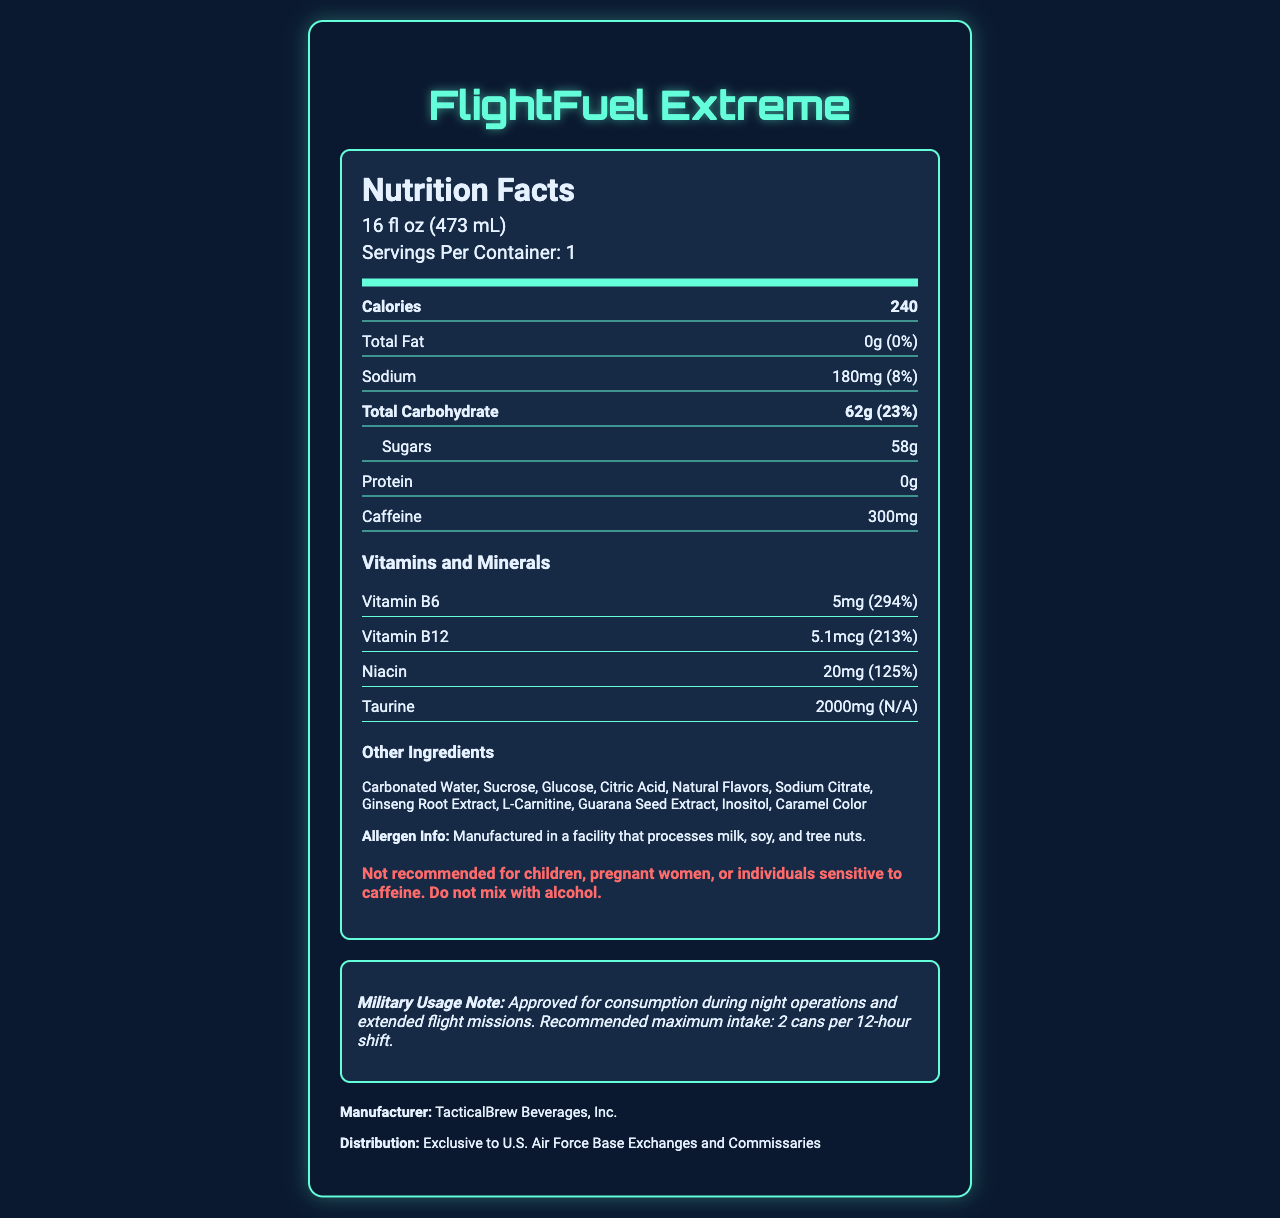what is the serving size of FlightFuel Extreme? The serving size is clearly mentioned near the top of the nutrition label.
Answer: 16 fl oz (473 mL) how many calories does one serving of FlightFuel Extreme contain? It is stated in the prominent "Calories" section of the label.
Answer: 240 what is the total carbohydrate content per serving? The amount is specifically listed under the "Total Carbohydrate" section in the nutrition label.
Answer: 62g what percentage of the daily value of sodium does one serving provide? This information is included next to the sodium content in the nutrition label.
Answer: 8% what are the two main sugars listed in FlightFuel Extreme? These sugars are listed under the "Other Ingredients" section.
Answer: Sucrose and Glucose what is the total fat content in FlightFuel Extreme? The total fat content is listed as 0g with a daily value of 0%.
Answer: 0g which vitamin is present in the highest percentage of daily value in FlightFuel Extreme? A. Vitamin B6 B. Vitamin B12 C. Niacin Vitamin B6 has 294% of the daily value, which is higher than Vitamin B12 at 213% and Niacin at 125%.
Answer: A. Vitamin B6 what is the caffeine content per serving of FlightFuel Extreme? The exact amount is provided under the "Caffeine" section in the label.
Answer: 300mg which of the following are included as other ingredients? (Select all that apply) 1. Ginseng Root Extract 2. Acai Berry 3. Guarana Seed Extract 4. Ashwagandha Ginseng Root Extract and Guarana Seed Extract are listed under "Other Ingredients," but Acai Berry and Ashwagandha are not.
Answer: 1, 3 is this energy drink recommended for children and pregnant women? The warning section clearly advises against consumption by children, pregnant women, or individuals sensitive to caffeine.
Answer: No summarize the main information provided in the FlightFuel Extreme nutrition label. The document provides detailed nutritional info, ingredients, warnings, and military usage notes for the energy drink.
Answer: FlightFuel Extreme is an energy drink designed for Air Force personnel with one 16 fl oz (473 mL) serving per container. It contains 240 calories, 0g fat, 180mg sodium (8% DV), 62g total carbohydrates (23% DV), 58g sugars, and 300mg caffeine. It is enriched with vitamins such as Vitamin B6 (294% DV), Vitamin B12 (213% DV), and Niacin (125% DV), along with 2000mg Taurine. Other ingredients include carbonated water, sucrose, glucose, and several extracts. The drink has warnings for children, pregnant women, and those sensitive to caffeine, and is meant for military use. what is the maximum recommended intake of FlightFuel Extreme during a 12-hour shift? The military usage note specifies that the recommended maximum intake is 2 cans per 12-hour shift.
Answer: 2 cans where can FlightFuel Extreme be purchased? Distribution information states its availability is limited to specific military locations.
Answer: Exclusive to U.S. Air Force Base Exchanges and Commissaries what is the purpose of the warning note? The warning note advises certain groups (children, pregnant women, etc.) against consuming the product and warns not to mix with alcohol.
Answer: To inform consumers about potential risks and contraindications is FlightFuel Extreme calorie-free? The product contains 240 calories per serving, as clearly specified in the nutrition facts.
Answer: No which company manufactures FlightFuel Extreme? The manufacturer's name is listed at the end of the document.
Answer: TacticalBrew Beverages, Inc. what is the impact on daily value percentages for protein? The document lists 0g protein but does not provide a daily value percentage, resulting in insufficient data.
Answer: Not enough information 